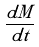<formula> <loc_0><loc_0><loc_500><loc_500>\frac { d M } { d t }</formula> 